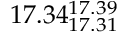Convert formula to latex. <formula><loc_0><loc_0><loc_500><loc_500>1 7 . 3 4 _ { 1 7 . 3 1 } ^ { 1 7 . 3 9 }</formula> 